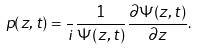<formula> <loc_0><loc_0><loc_500><loc_500>p ( z , t ) = \frac { } { i } \frac { 1 } { \Psi ( z , t ) } \frac { \partial \Psi ( z , t ) } { \partial z } .</formula> 